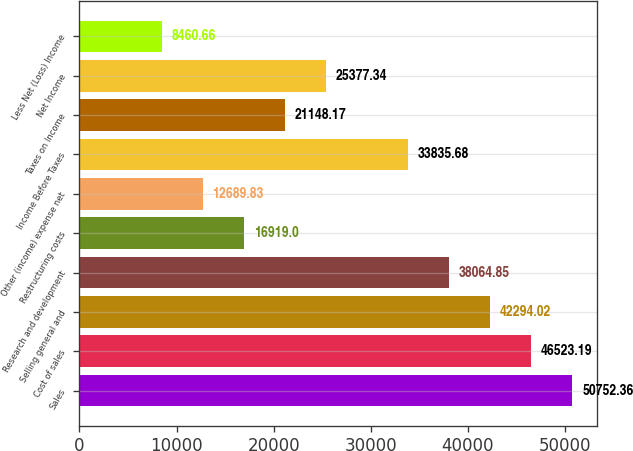<chart> <loc_0><loc_0><loc_500><loc_500><bar_chart><fcel>Sales<fcel>Cost of sales<fcel>Selling general and<fcel>Research and development<fcel>Restructuring costs<fcel>Other (income) expense net<fcel>Income Before Taxes<fcel>Taxes on Income<fcel>Net Income<fcel>Less Net (Loss) Income<nl><fcel>50752.4<fcel>46523.2<fcel>42294<fcel>38064.8<fcel>16919<fcel>12689.8<fcel>33835.7<fcel>21148.2<fcel>25377.3<fcel>8460.66<nl></chart> 